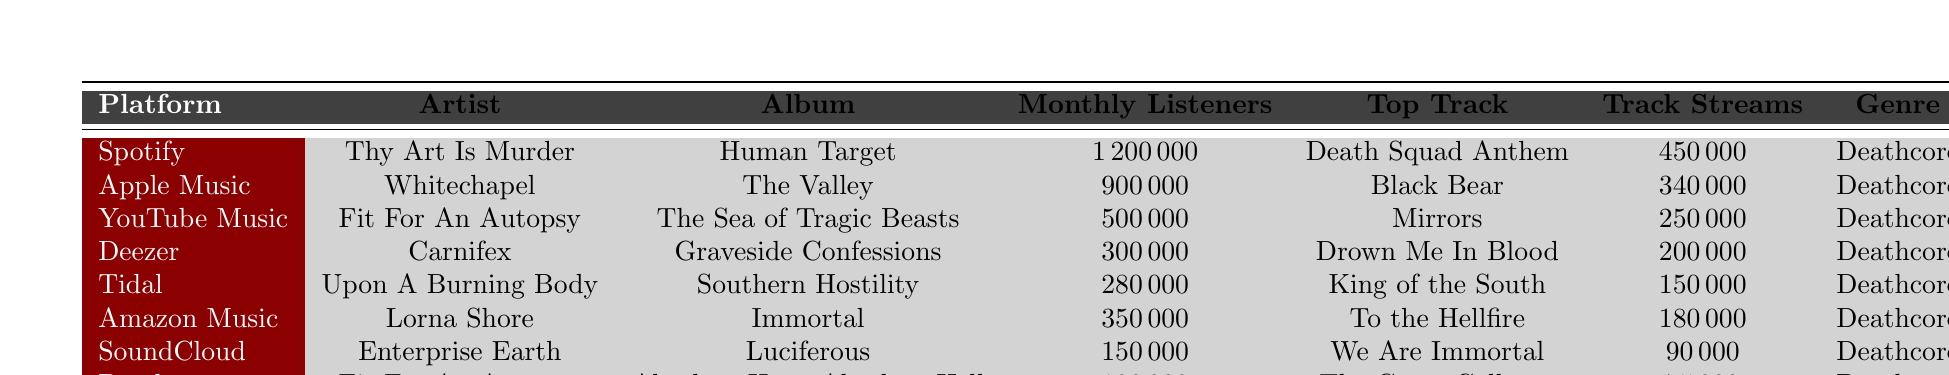What is the top track of Lorna Shore? According to the table, Lorna Shore's top track is "To the Hellfire."
Answer: To the Hellfire Which platform has the highest number of monthly listeners for deathcore music? The table shows that Spotify has the highest number of monthly listeners with 1,200,000.
Answer: Spotify How many total monthly listeners do the deathcore artists on Tidal and Deezer have together? The monthly listeners for Tidal is 280,000 and for Deezer is 300,000. Adding these gives 280,000 + 300,000 = 580,000 total monthly listeners.
Answer: 580,000 Is "Fit For An Autopsy" the artist with the most streams for a single track on YouTube Music? The table indicates that "Fit For An Autopsy" has 250,000 track streams for their top track "Mirrors" on YouTube Music, while Thy Art Is Murder's "Death Squad Anthem" has 450,000 streams. Thus, "Fit For An Autopsy" does not have the most streams.
Answer: No Which artist has the lowest monthly listeners? Looking at the table, Enterprise Earth has the lowest monthly listeners with 150,000.
Answer: Enterprise Earth What is the average number of track streams for all the artists listed? The sum of all track streams is (450000 + 340000 + 250000 + 200000 + 150000 + 180000 + 90000 + 75000) = 1,655,000. There are 8 artists, so the average is 1,655,000 / 8 = 206,875.
Answer: 206,875 Which album by "Fit For An Autopsy" has the highest monthly listeners? Fit For An Autopsy appears twice in the table with albums 'The Sea of Tragic Beasts' and 'Absolute Hope Absolute Hell', having 500,000 and 100,000 monthly listeners respectively. Therefore, 'The Sea of Tragic Beasts' has the higher number.
Answer: The Sea of Tragic Beasts Are there any platforms where more than one artist is listed? Examining the table shows that "Fit For An Autopsy" is listed twice, but other platforms have only one artist each. Thus, only Bandcamp and YouTube Music have multiple listings for the same artist.
Answer: Yes, for Fit For An Autopsy Which genre is associated with all the artists in the table? By checking each row in the table, all listed artists are categorized under the genre "Deathcore."
Answer: Deathcore What is the difference in monthly listeners between the top two platforms? The top two platforms are Spotify and Apple Music, with 1,200,000 and 900,000 monthly listeners respectively. The difference is 1,200,000 - 900,000 = 300,000.
Answer: 300,000 